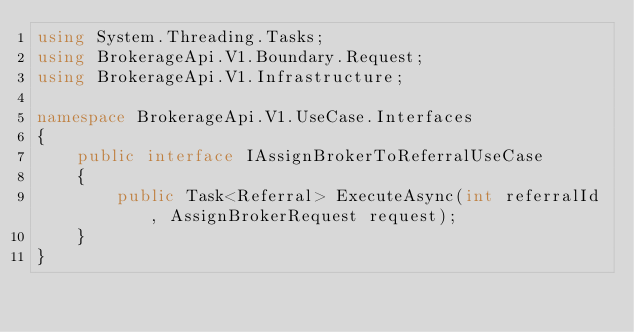Convert code to text. <code><loc_0><loc_0><loc_500><loc_500><_C#_>using System.Threading.Tasks;
using BrokerageApi.V1.Boundary.Request;
using BrokerageApi.V1.Infrastructure;

namespace BrokerageApi.V1.UseCase.Interfaces
{
    public interface IAssignBrokerToReferralUseCase
    {
        public Task<Referral> ExecuteAsync(int referralId, AssignBrokerRequest request);
    }
}
</code> 